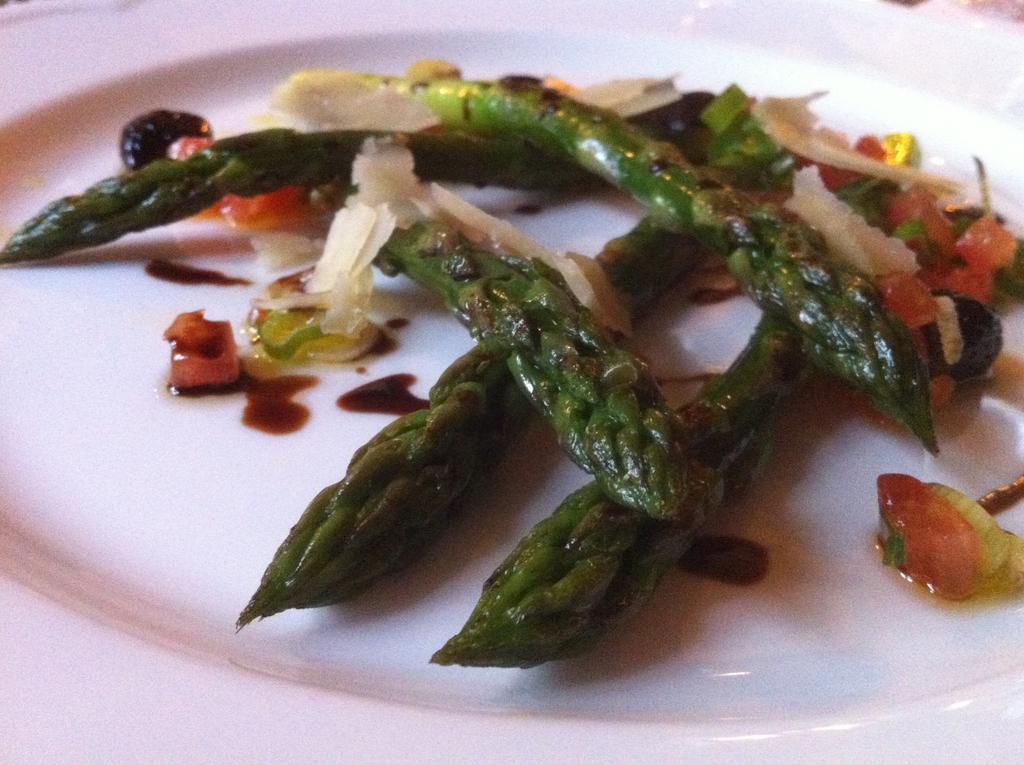Could you give a brief overview of what you see in this image? In this image there is a plate, and in the plate there is dish. 